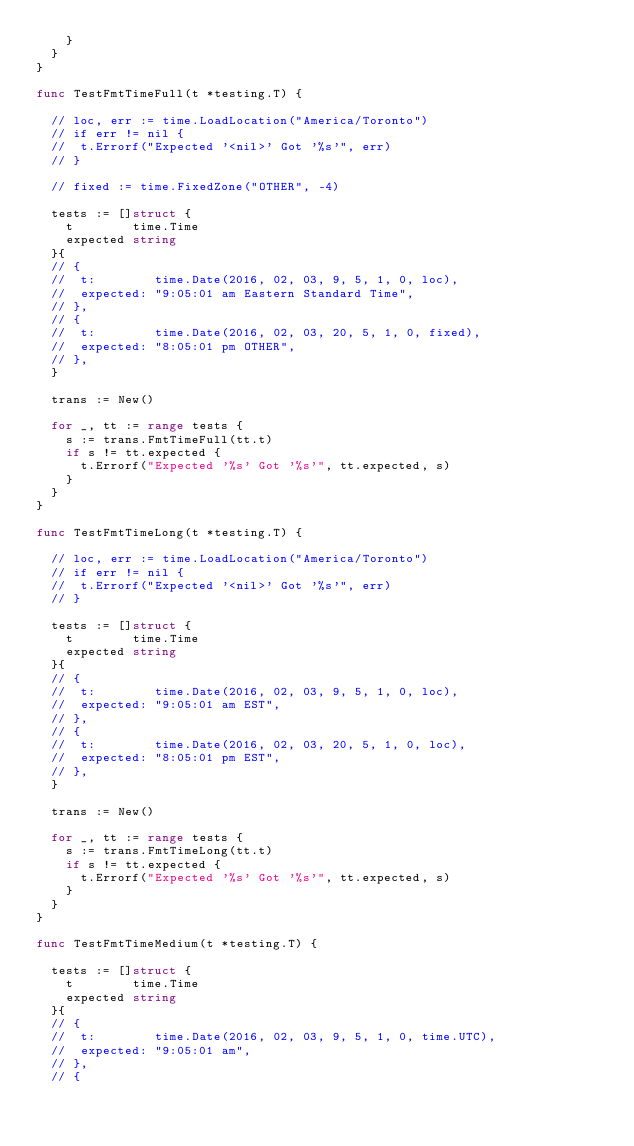Convert code to text. <code><loc_0><loc_0><loc_500><loc_500><_Go_>		}
	}
}

func TestFmtTimeFull(t *testing.T) {

	// loc, err := time.LoadLocation("America/Toronto")
	// if err != nil {
	// 	t.Errorf("Expected '<nil>' Got '%s'", err)
	// }

	// fixed := time.FixedZone("OTHER", -4)

	tests := []struct {
		t        time.Time
		expected string
	}{
	// {
	// 	t:        time.Date(2016, 02, 03, 9, 5, 1, 0, loc),
	// 	expected: "9:05:01 am Eastern Standard Time",
	// },
	// {
	// 	t:        time.Date(2016, 02, 03, 20, 5, 1, 0, fixed),
	// 	expected: "8:05:01 pm OTHER",
	// },
	}

	trans := New()

	for _, tt := range tests {
		s := trans.FmtTimeFull(tt.t)
		if s != tt.expected {
			t.Errorf("Expected '%s' Got '%s'", tt.expected, s)
		}
	}
}

func TestFmtTimeLong(t *testing.T) {

	// loc, err := time.LoadLocation("America/Toronto")
	// if err != nil {
	// 	t.Errorf("Expected '<nil>' Got '%s'", err)
	// }

	tests := []struct {
		t        time.Time
		expected string
	}{
	// {
	// 	t:        time.Date(2016, 02, 03, 9, 5, 1, 0, loc),
	// 	expected: "9:05:01 am EST",
	// },
	// {
	// 	t:        time.Date(2016, 02, 03, 20, 5, 1, 0, loc),
	// 	expected: "8:05:01 pm EST",
	// },
	}

	trans := New()

	for _, tt := range tests {
		s := trans.FmtTimeLong(tt.t)
		if s != tt.expected {
			t.Errorf("Expected '%s' Got '%s'", tt.expected, s)
		}
	}
}

func TestFmtTimeMedium(t *testing.T) {

	tests := []struct {
		t        time.Time
		expected string
	}{
	// {
	// 	t:        time.Date(2016, 02, 03, 9, 5, 1, 0, time.UTC),
	// 	expected: "9:05:01 am",
	// },
	// {</code> 